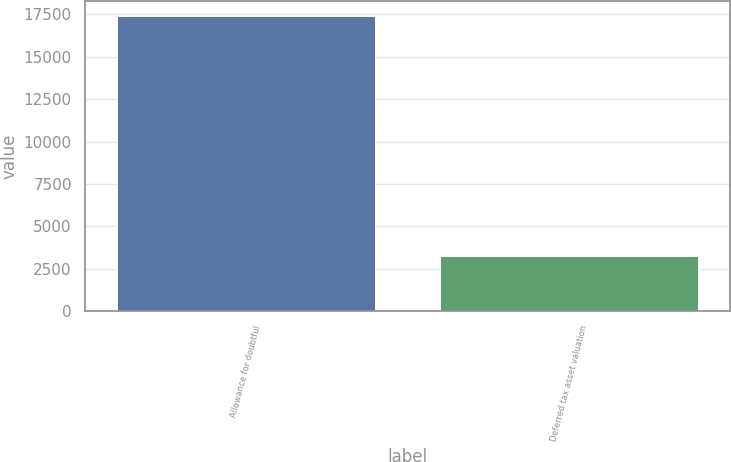<chart> <loc_0><loc_0><loc_500><loc_500><bar_chart><fcel>Allowance for doubtful<fcel>Deferred tax asset valuation<nl><fcel>17412<fcel>3257<nl></chart> 